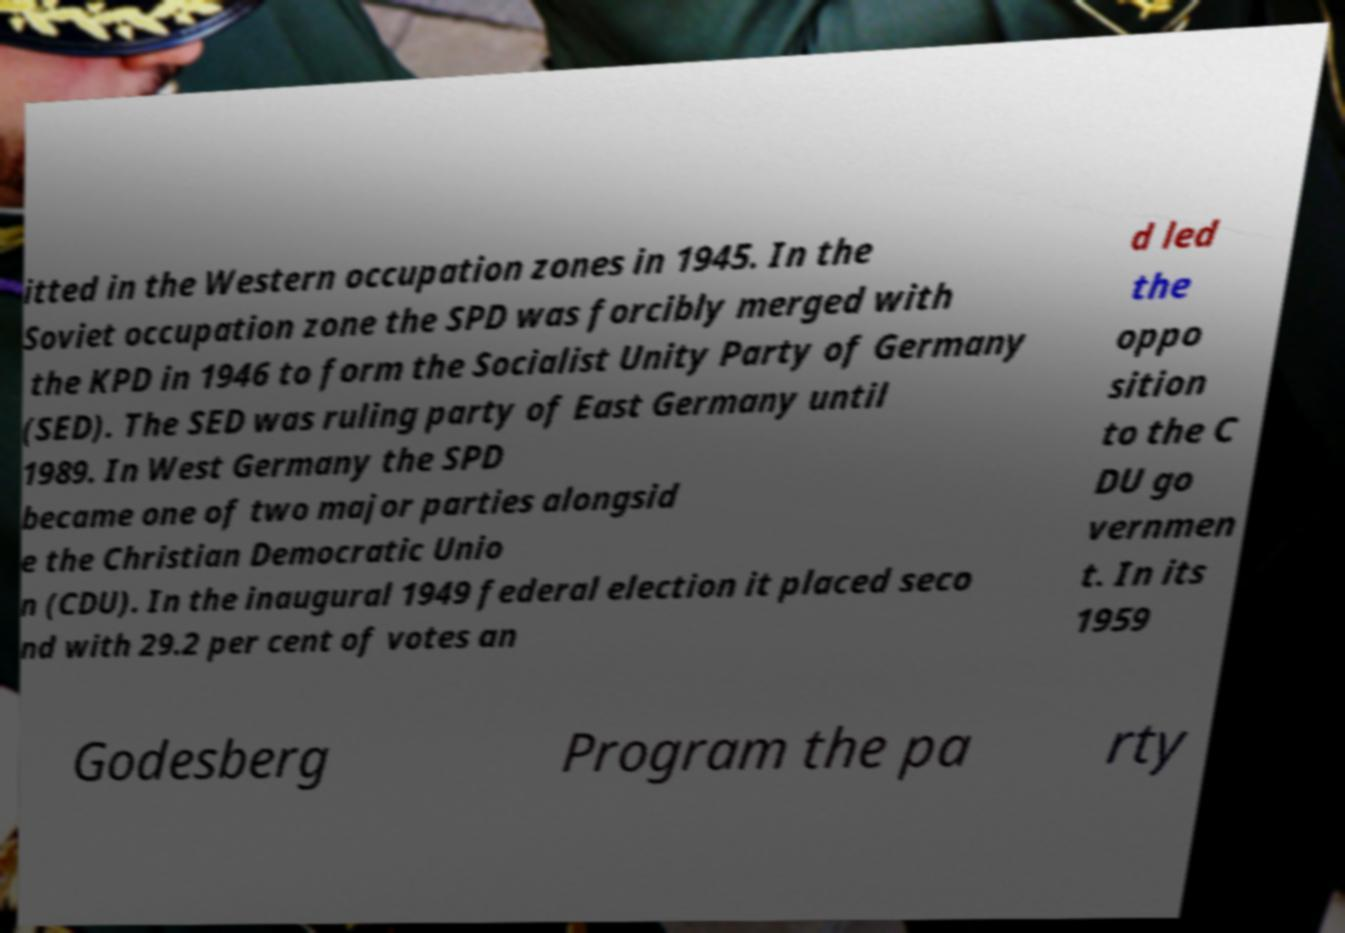There's text embedded in this image that I need extracted. Can you transcribe it verbatim? itted in the Western occupation zones in 1945. In the Soviet occupation zone the SPD was forcibly merged with the KPD in 1946 to form the Socialist Unity Party of Germany (SED). The SED was ruling party of East Germany until 1989. In West Germany the SPD became one of two major parties alongsid e the Christian Democratic Unio n (CDU). In the inaugural 1949 federal election it placed seco nd with 29.2 per cent of votes an d led the oppo sition to the C DU go vernmen t. In its 1959 Godesberg Program the pa rty 